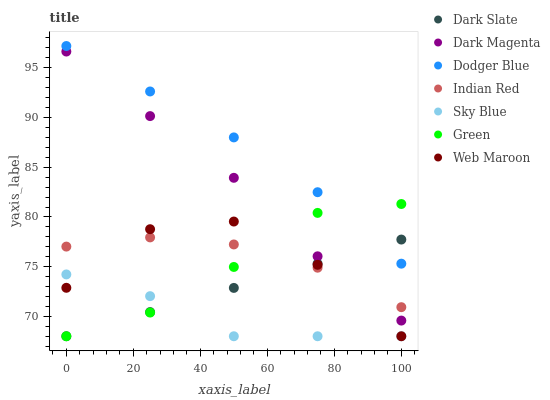Does Sky Blue have the minimum area under the curve?
Answer yes or no. Yes. Does Dodger Blue have the maximum area under the curve?
Answer yes or no. Yes. Does Web Maroon have the minimum area under the curve?
Answer yes or no. No. Does Web Maroon have the maximum area under the curve?
Answer yes or no. No. Is Dark Slate the smoothest?
Answer yes or no. Yes. Is Web Maroon the roughest?
Answer yes or no. Yes. Is Web Maroon the smoothest?
Answer yes or no. No. Is Dark Slate the roughest?
Answer yes or no. No. Does Web Maroon have the lowest value?
Answer yes or no. Yes. Does Indian Red have the lowest value?
Answer yes or no. No. Does Dodger Blue have the highest value?
Answer yes or no. Yes. Does Web Maroon have the highest value?
Answer yes or no. No. Is Dark Magenta less than Dodger Blue?
Answer yes or no. Yes. Is Dodger Blue greater than Indian Red?
Answer yes or no. Yes. Does Indian Red intersect Dark Slate?
Answer yes or no. Yes. Is Indian Red less than Dark Slate?
Answer yes or no. No. Is Indian Red greater than Dark Slate?
Answer yes or no. No. Does Dark Magenta intersect Dodger Blue?
Answer yes or no. No. 